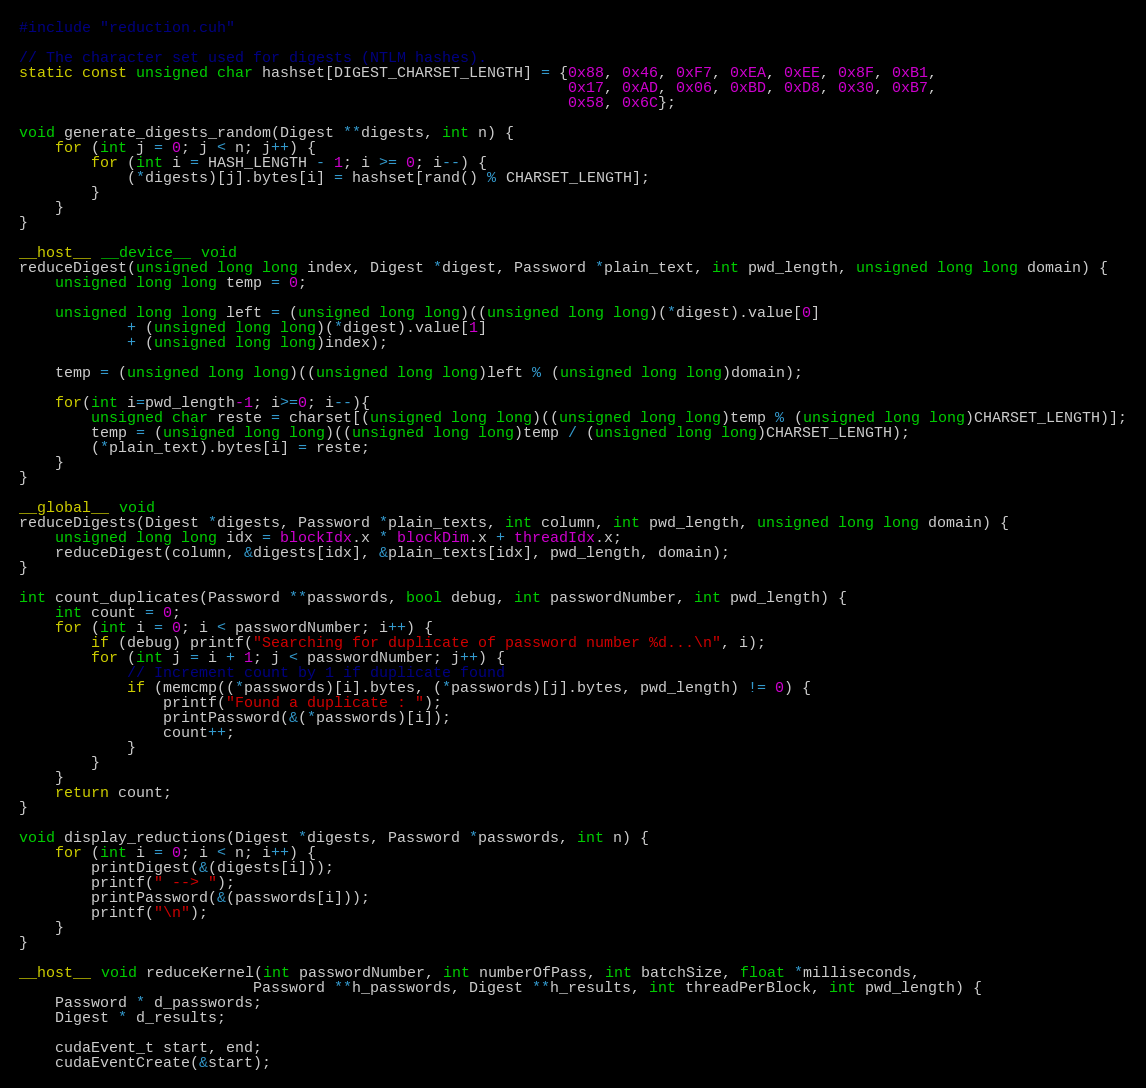<code> <loc_0><loc_0><loc_500><loc_500><_Cuda_>#include "reduction.cuh"

// The character set used for digests (NTLM hashes).
static const unsigned char hashset[DIGEST_CHARSET_LENGTH] = {0x88, 0x46, 0xF7, 0xEA, 0xEE, 0x8F, 0xB1,
                                                             0x17, 0xAD, 0x06, 0xBD, 0xD8, 0x30, 0xB7,
                                                             0x58, 0x6C};

void generate_digests_random(Digest **digests, int n) {
    for (int j = 0; j < n; j++) {
        for (int i = HASH_LENGTH - 1; i >= 0; i--) {
            (*digests)[j].bytes[i] = hashset[rand() % CHARSET_LENGTH];
        }
    }
}

__host__ __device__ void
reduceDigest(unsigned long long index, Digest *digest, Password *plain_text, int pwd_length, unsigned long long domain) {
    unsigned long long temp = 0;

    unsigned long long left = (unsigned long long)((unsigned long long)(*digest).value[0]
            + (unsigned long long)(*digest).value[1]
            + (unsigned long long)index);

    temp = (unsigned long long)((unsigned long long)left % (unsigned long long)domain);

    for(int i=pwd_length-1; i>=0; i--){
        unsigned char reste = charset[(unsigned long long)((unsigned long long)temp % (unsigned long long)CHARSET_LENGTH)];
        temp = (unsigned long long)((unsigned long long)temp / (unsigned long long)CHARSET_LENGTH);
        (*plain_text).bytes[i] = reste;
    }
}

__global__ void
reduceDigests(Digest *digests, Password *plain_texts, int column, int pwd_length, unsigned long long domain) {
    unsigned long long idx = blockIdx.x * blockDim.x + threadIdx.x;
    reduceDigest(column, &digests[idx], &plain_texts[idx], pwd_length, domain);
}

int count_duplicates(Password **passwords, bool debug, int passwordNumber, int pwd_length) {
    int count = 0;
    for (int i = 0; i < passwordNumber; i++) {
        if (debug) printf("Searching for duplicate of password number %d...\n", i);
        for (int j = i + 1; j < passwordNumber; j++) {
            // Increment count by 1 if duplicate found
            if (memcmp((*passwords)[i].bytes, (*passwords)[j].bytes, pwd_length) != 0) {
                printf("Found a duplicate : ");
                printPassword(&(*passwords)[i]);
                count++;
            }
        }
    }
    return count;
}

void display_reductions(Digest *digests, Password *passwords, int n) {
    for (int i = 0; i < n; i++) {
        printDigest(&(digests[i]));
        printf(" --> ");
        printPassword(&(passwords[i]));
        printf("\n");
    }
}

__host__ void reduceKernel(int passwordNumber, int numberOfPass, int batchSize, float *milliseconds,
                          Password **h_passwords, Digest **h_results, int threadPerBlock, int pwd_length) {
    Password * d_passwords;
    Digest * d_results;

    cudaEvent_t start, end;
    cudaEventCreate(&start);</code> 